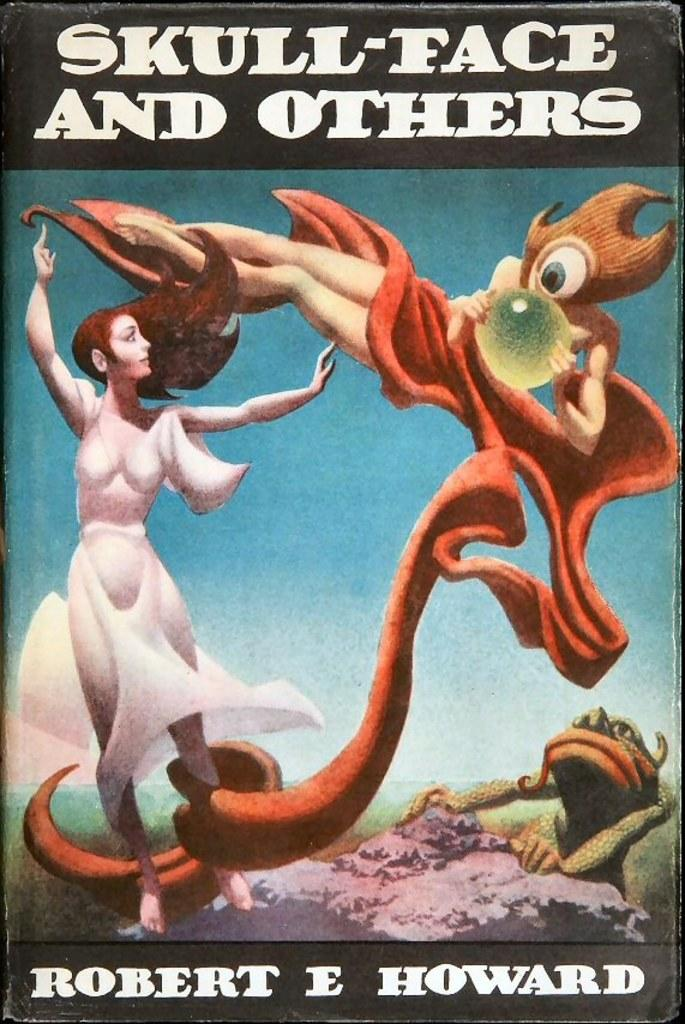<image>
Render a clear and concise summary of the photo. an item that says skull face and others on it 